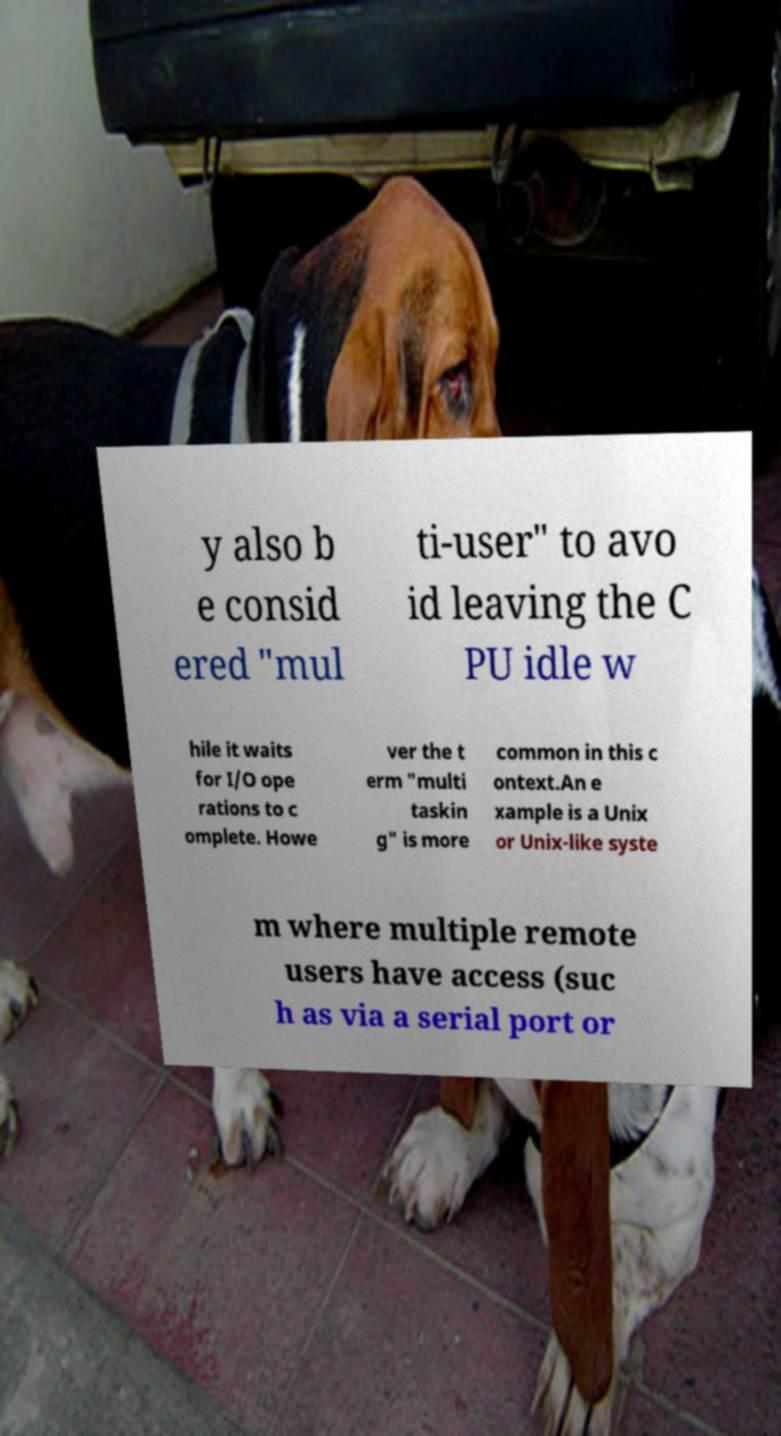Could you extract and type out the text from this image? y also b e consid ered "mul ti-user" to avo id leaving the C PU idle w hile it waits for I/O ope rations to c omplete. Howe ver the t erm "multi taskin g" is more common in this c ontext.An e xample is a Unix or Unix-like syste m where multiple remote users have access (suc h as via a serial port or 